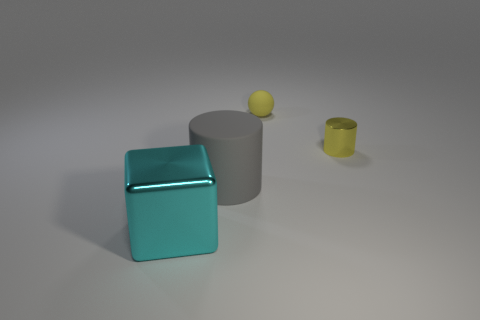Can you speculate on the sizes of these objects based on their shadows? Certainly! The shadows suggest all objects are relatively small; however, the blue cube casts the largest shadow indicating it may be the biggest object in the scene. The yellow cylinder's shadow is narrow and elongated, suggesting it has a small, possibly cylindrical base. The shadows allow for an estimation of the objects' proportions in relation to one another. What materials could these objects be made of? The blue cube exhibits characteristics of a polished metal or plastic, reflective and smooth. The gray cylinder seems to be made of a non-reflective material, possibly rubber or matte-finish plastic. The yellow sphere and cylinder could also be metallic, given their shiny surfaces, indicative of materials such as polished brass or gold-tinted metal. 